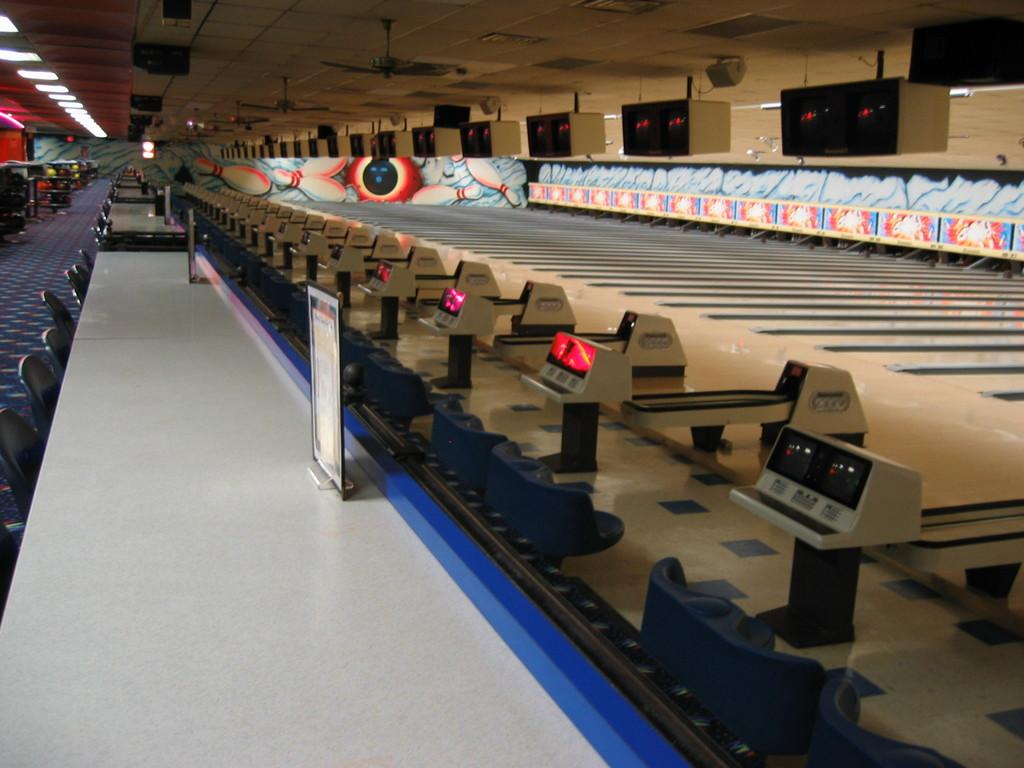What type of furniture is present in the image? There is a table and chairs in the image. What is on the wall in the image? There is a black color television on the wall. What type of appliances are present in the image? There are ceiling fans in the image. What type of lighting is present in the image? There are lights in the image. Can you see any plantation in the image? There is no plantation present in the image. Is there a flame visible in the image? There is no flame visible in the image. 